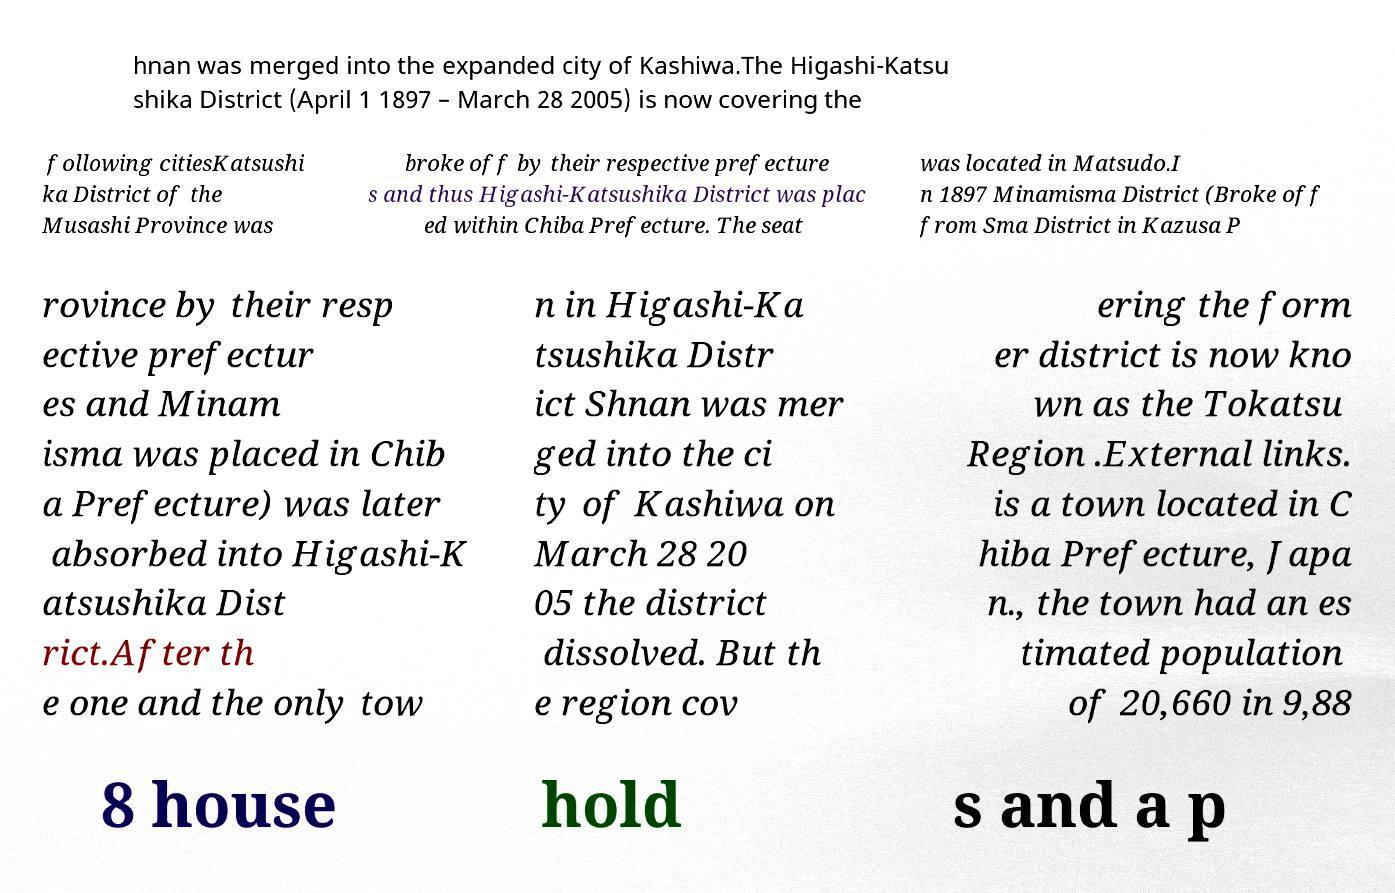Can you accurately transcribe the text from the provided image for me? hnan was merged into the expanded city of Kashiwa.The Higashi-Katsu shika District (April 1 1897 – March 28 2005) is now covering the following citiesKatsushi ka District of the Musashi Province was broke off by their respective prefecture s and thus Higashi-Katsushika District was plac ed within Chiba Prefecture. The seat was located in Matsudo.I n 1897 Minamisma District (Broke off from Sma District in Kazusa P rovince by their resp ective prefectur es and Minam isma was placed in Chib a Prefecture) was later absorbed into Higashi-K atsushika Dist rict.After th e one and the only tow n in Higashi-Ka tsushika Distr ict Shnan was mer ged into the ci ty of Kashiwa on March 28 20 05 the district dissolved. But th e region cov ering the form er district is now kno wn as the Tokatsu Region .External links. is a town located in C hiba Prefecture, Japa n., the town had an es timated population of 20,660 in 9,88 8 house hold s and a p 